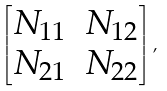<formula> <loc_0><loc_0><loc_500><loc_500>\begin{bmatrix} N _ { 1 1 } & N _ { 1 2 } \\ N _ { 2 1 } & N _ { 2 2 } \end{bmatrix} ,</formula> 